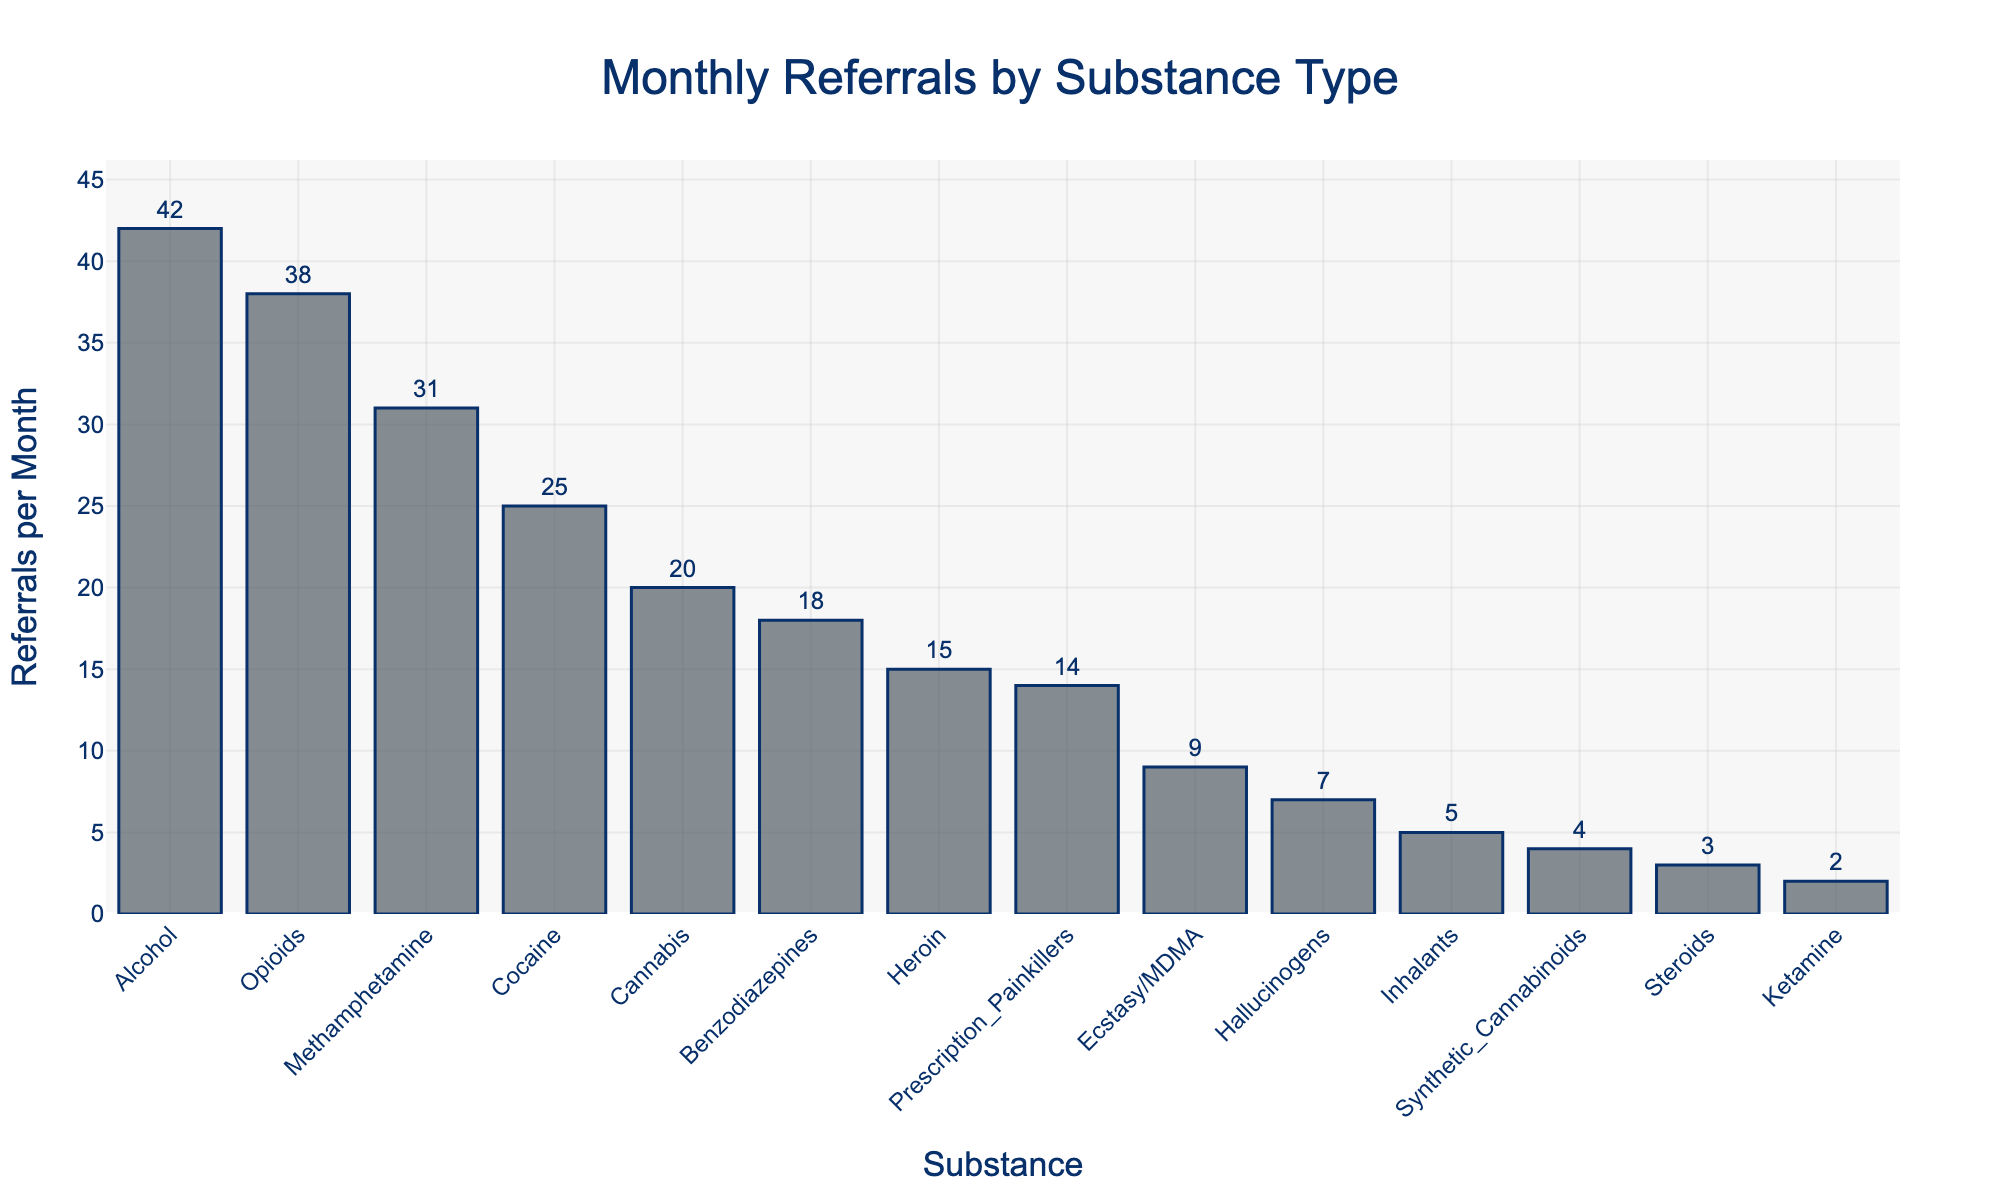What substance has the highest number of referrals per month? By looking at the tallest bar, we see that Alcohol has the highest number of referrals.
Answer: Alcohol Which two substances have the closest number of monthly referrals, and what are those values? By examining the bars, we see that Opioids and Methamphetamine are very close in height. The values are 38 (Opioids) and 31 (Methamphetamine).
Answer: Opioids (38) and Methamphetamine (31) What is the total number of monthly referrals for all substances combined? Sum the referral numbers for each substance: 42 + 38 + 31 + 25 + 20 + 18 + 15 + 14 + 9 + 7 + 5 + 4 + 3 + 2 = 233.
Answer: 233 Which substances have fewer than 10 referrals per month, and how many do they have? We identify the shorter bars and their values: Ecstasy/MDMA (9), Hallucinogens (7), Inhalants (5), Synthetic Cannabinoids (4), Steroids (3), and Ketamine (2).
Answer: Ecstasy/MDMA (9), Hallucinogens (7), Inhalants (5), Synthetic Cannabinoids (4), Steroids (3), Ketamine (2) How much higher is the number of referrals for Alcohol than for Heroin? Alcohol has 42 referrals, while Heroin has 15. The difference is 42 - 15 = 27.
Answer: 27 What is the average number of referrals per month across all substances? Calculate the total first (233) and then divide by the number of substances (14): 233 / 14 ≈ 16.64.
Answer: 16.64 Which substance has the smallest number of monthly referrals, and what is that value? By identifying the shortest bar, we see that Ketamine has the smallest number with 2 referrals.
Answer: Ketamine (2) Which substance has a referral count closest to the average number of referrals per month? The average is approximately 16.64. Examine the bars to find the substance closest to this value. Benzodiazepines have 18, which is closest.
Answer: Benzodiazepines (18) What is the difference in the number of referrals between Cocaine and Benzodiazepines? Cocaine has 25 referrals, and Benzodiazepines have 18. The difference is 25 - 18 = 7.
Answer: 7 